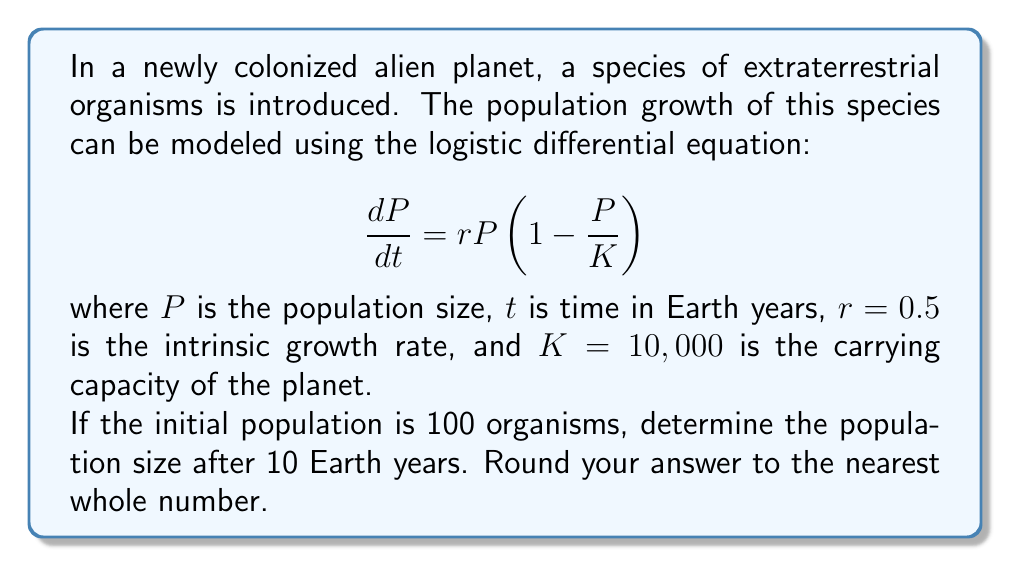Can you solve this math problem? To solve this problem, we need to integrate the logistic differential equation. The solution to the logistic equation is given by:

$$P(t) = \frac{K}{1 + \left(\frac{K}{P_0} - 1\right)e^{-rt}}$$

where $P_0$ is the initial population.

Let's substitute the given values:
$K = 10,000$
$r = 0.5$
$P_0 = 100$
$t = 10$

$$P(10) = \frac{10,000}{1 + \left(\frac{10,000}{100} - 1\right)e^{-0.5 \cdot 10}}$$

$$= \frac{10,000}{1 + 99e^{-5}}$$

$$= \frac{10,000}{1 + 99 \cdot 0.006737}$$

$$= \frac{10,000}{1 + 0.666963}$$

$$= \frac{10,000}{1.666963}$$

$$\approx 5,998.3$$

Rounding to the nearest whole number, we get 5,998.
Answer: 5,998 